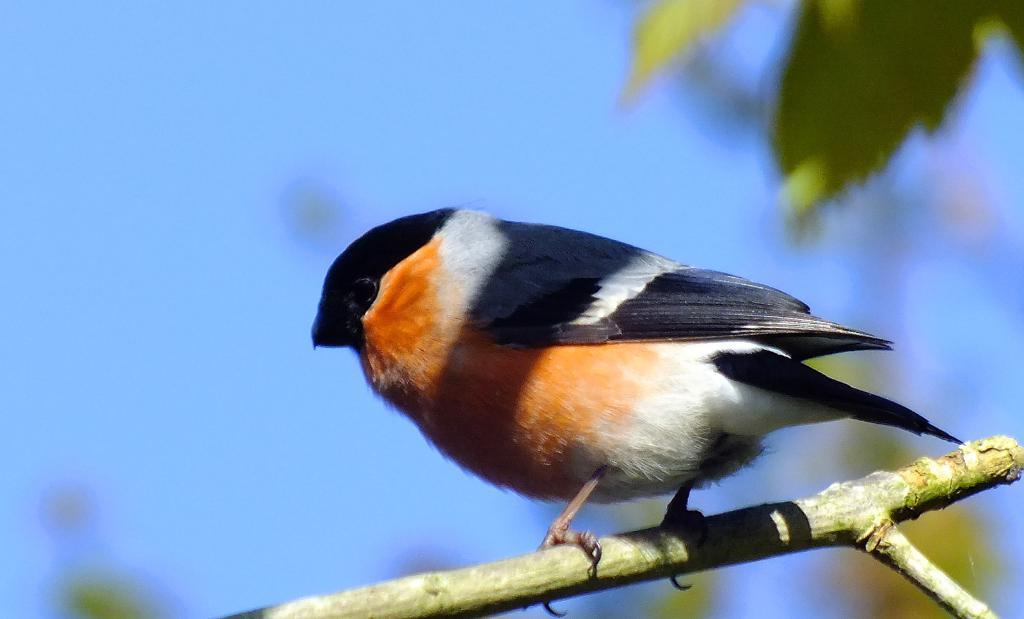What type of animal can be seen in the picture? There is a bird in the picture. Where is the bird located in the picture? The bird is on a branch. What colors can be observed on the bird? The bird has white, orange, and black colors. What else can be seen in the picture besides the bird? There are leaves visible in the picture. What is the condition of the sky in the background? The sky is cloudy in the background. Can you tell me how many icicles are hanging from the branch in the image? There are no icicles present in the image; it features a bird on a branch with leaves and a cloudy sky in the background. What time of day is it in the image? The time of day cannot be determined from the image, as there are no specific clues or indicators present. 